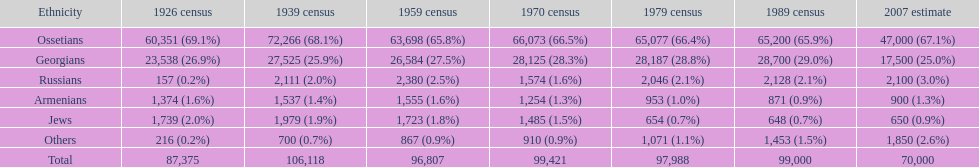What was the population of russians in south ossetia in 1970? 1,574. 